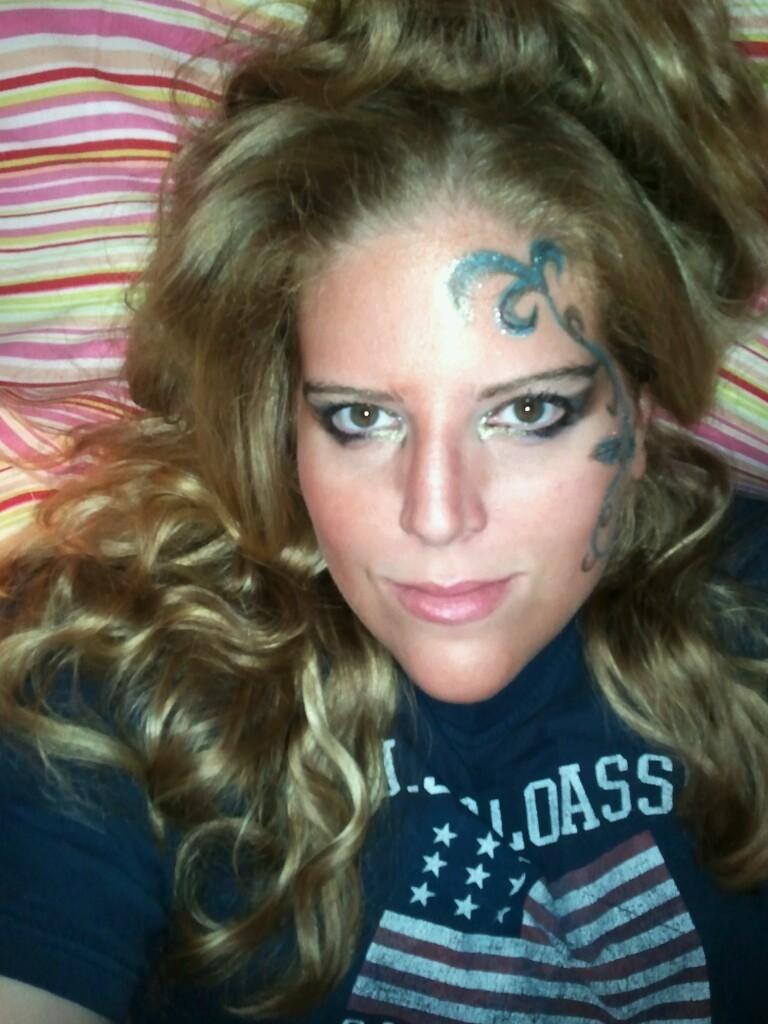Who is present in the image? There is a woman in the image. What is the woman wearing? The woman is wearing a t-shirt. What is the woman's facial expression? The woman is smiling. What is the woman looking at? The woman is looking at a picture. What can be seen in the background of the image? There is a cloth visible in the background of the image. How does the woman change the light bulb in the image? There is no light bulb present in the image, so the woman cannot change it. 